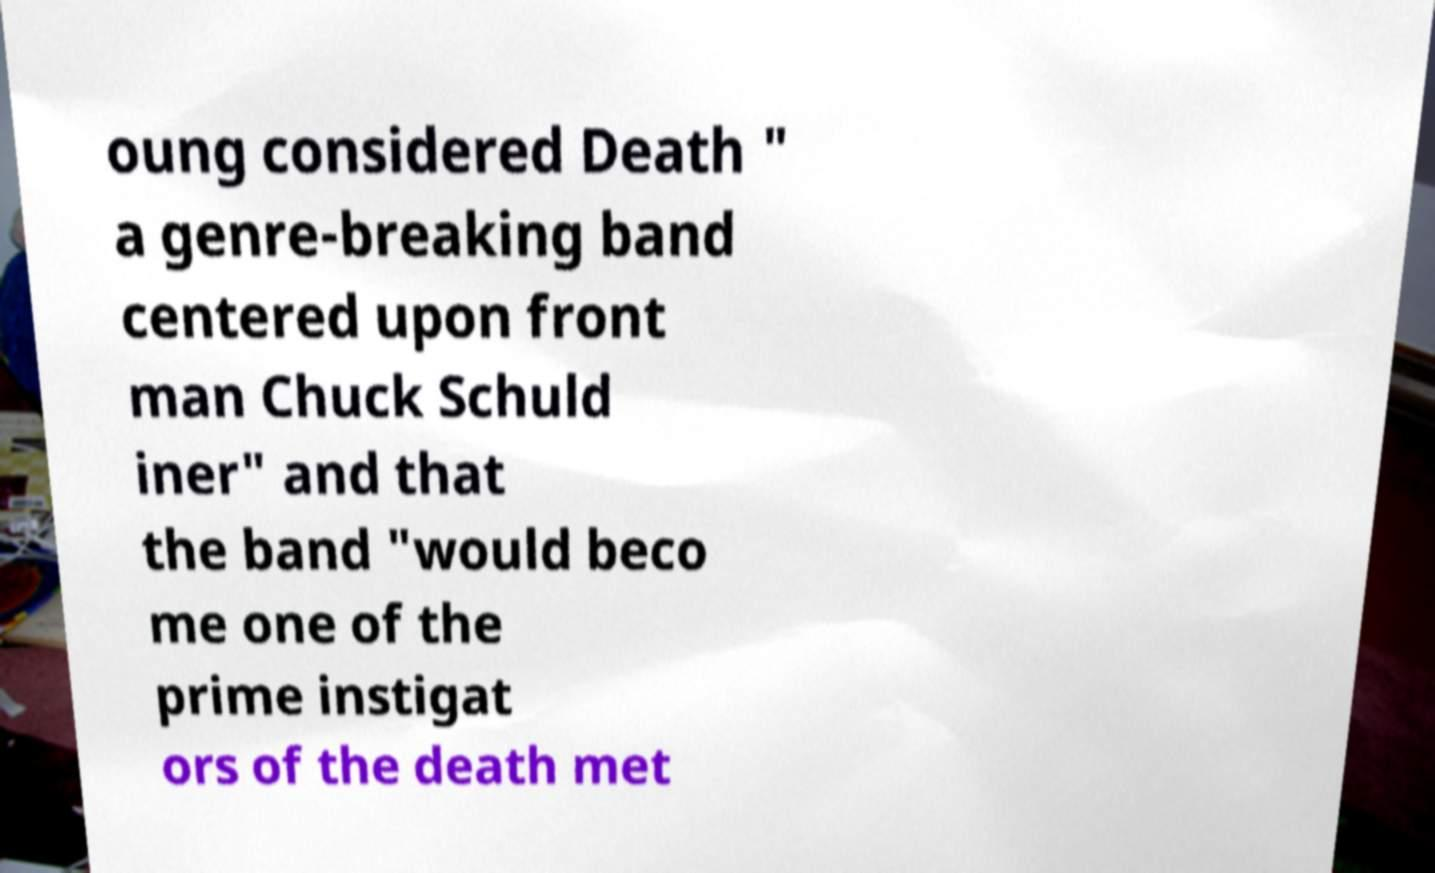Can you read and provide the text displayed in the image?This photo seems to have some interesting text. Can you extract and type it out for me? oung considered Death " a genre-breaking band centered upon front man Chuck Schuld iner" and that the band "would beco me one of the prime instigat ors of the death met 